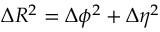<formula> <loc_0><loc_0><loc_500><loc_500>\Delta R ^ { 2 } = \Delta \phi ^ { 2 } + \Delta \eta ^ { 2 }</formula> 